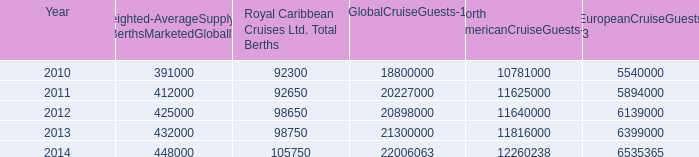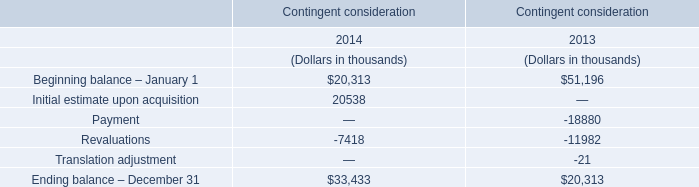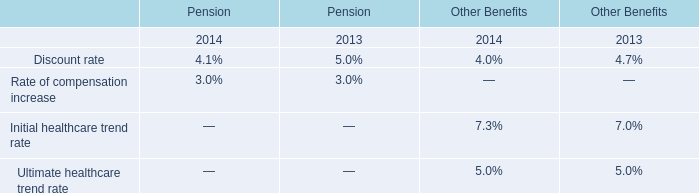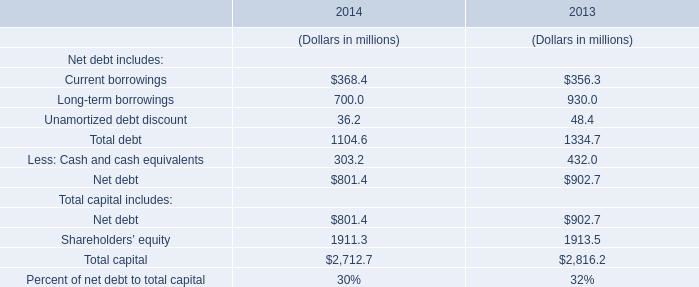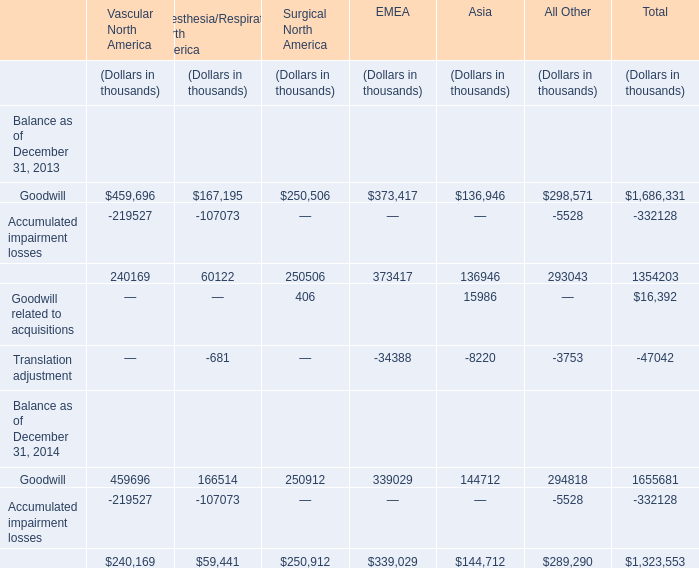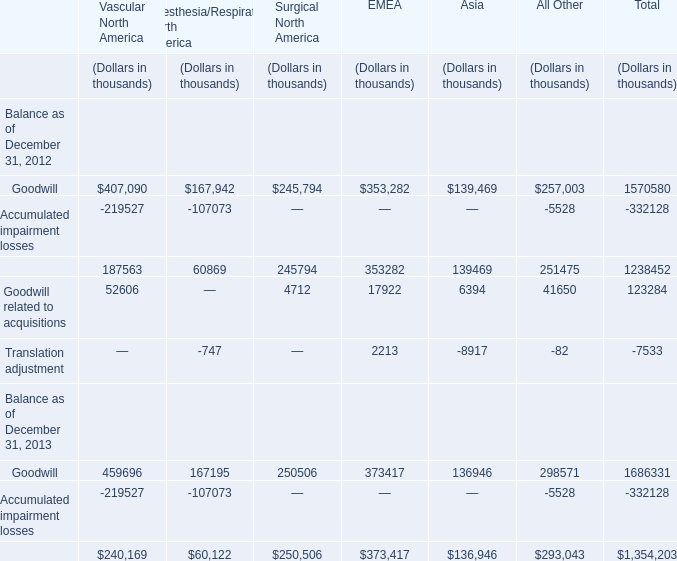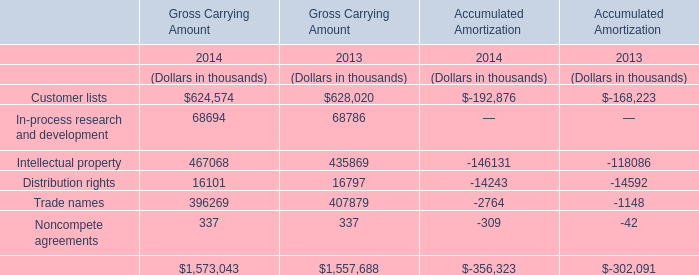What is the sum of goodwill in 2012 ? (in thousand) 
Computations: (((((407090 + 167942) + 245794) + 353282) + 139469) + 257003)
Answer: 1570580.0. 